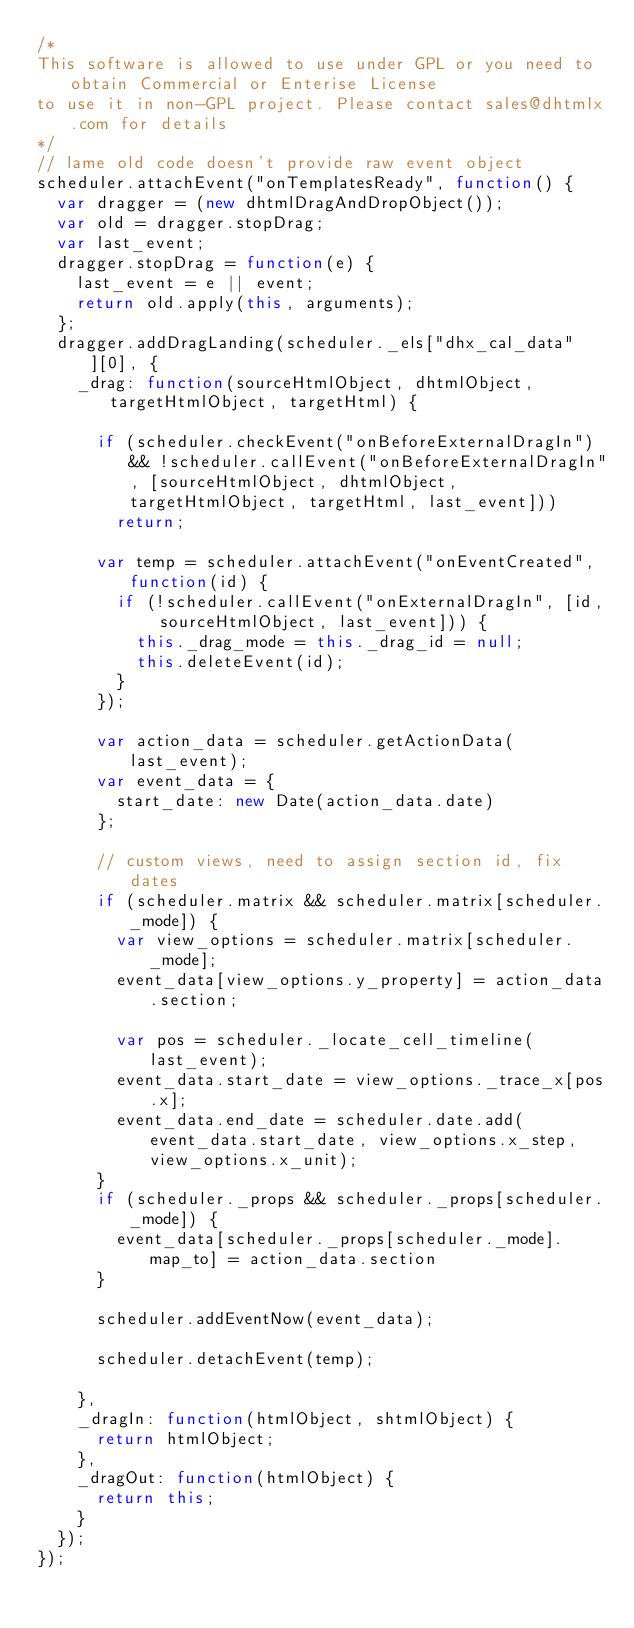<code> <loc_0><loc_0><loc_500><loc_500><_JavaScript_>/*
This software is allowed to use under GPL or you need to obtain Commercial or Enterise License
to use it in non-GPL project. Please contact sales@dhtmlx.com for details
*/
// lame old code doesn't provide raw event object
scheduler.attachEvent("onTemplatesReady", function() {
	var dragger = (new dhtmlDragAndDropObject());
	var old = dragger.stopDrag;
	var last_event;
	dragger.stopDrag = function(e) {
		last_event = e || event;
		return old.apply(this, arguments);
	};
	dragger.addDragLanding(scheduler._els["dhx_cal_data"][0], {
		_drag: function(sourceHtmlObject, dhtmlObject, targetHtmlObject, targetHtml) {

			if (scheduler.checkEvent("onBeforeExternalDragIn") && !scheduler.callEvent("onBeforeExternalDragIn", [sourceHtmlObject, dhtmlObject, targetHtmlObject, targetHtml, last_event]))
				return;

			var temp = scheduler.attachEvent("onEventCreated", function(id) {
				if (!scheduler.callEvent("onExternalDragIn", [id, sourceHtmlObject, last_event])) {
					this._drag_mode = this._drag_id = null;
					this.deleteEvent(id);
				}
			});

			var action_data = scheduler.getActionData(last_event);
			var event_data = {
				start_date: new Date(action_data.date)
			};

			// custom views, need to assign section id, fix dates
			if (scheduler.matrix && scheduler.matrix[scheduler._mode]) {
				var view_options = scheduler.matrix[scheduler._mode];
				event_data[view_options.y_property] = action_data.section;

				var pos = scheduler._locate_cell_timeline(last_event);
				event_data.start_date = view_options._trace_x[pos.x];
				event_data.end_date = scheduler.date.add(event_data.start_date, view_options.x_step, view_options.x_unit);
			}
			if (scheduler._props && scheduler._props[scheduler._mode]) {
				event_data[scheduler._props[scheduler._mode].map_to] = action_data.section
			}

			scheduler.addEventNow(event_data);

			scheduler.detachEvent(temp);

		},
		_dragIn: function(htmlObject, shtmlObject) {
			return htmlObject;
		},
		_dragOut: function(htmlObject) {
			return this;
		}
	});
});
</code> 